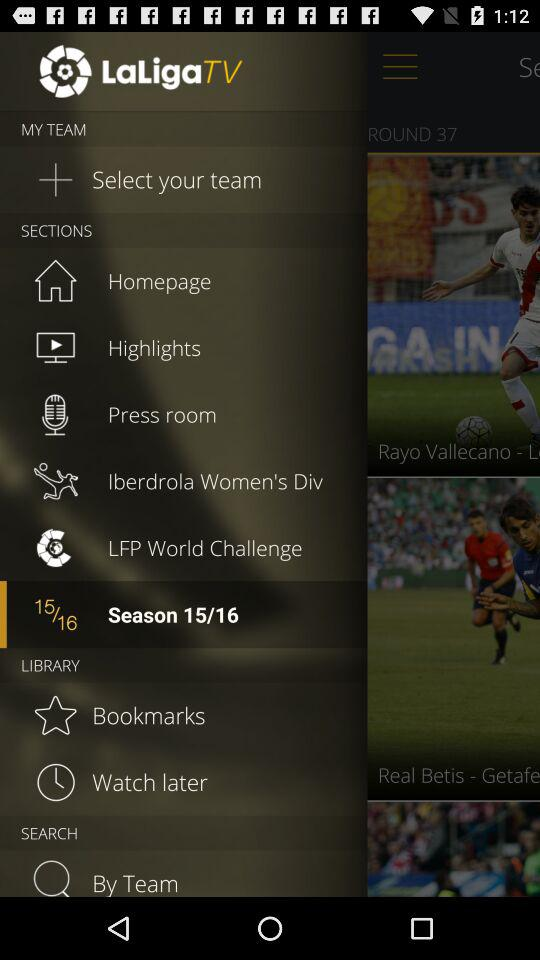How many total seasons are there?
When the provided information is insufficient, respond with <no answer>. <no answer> 